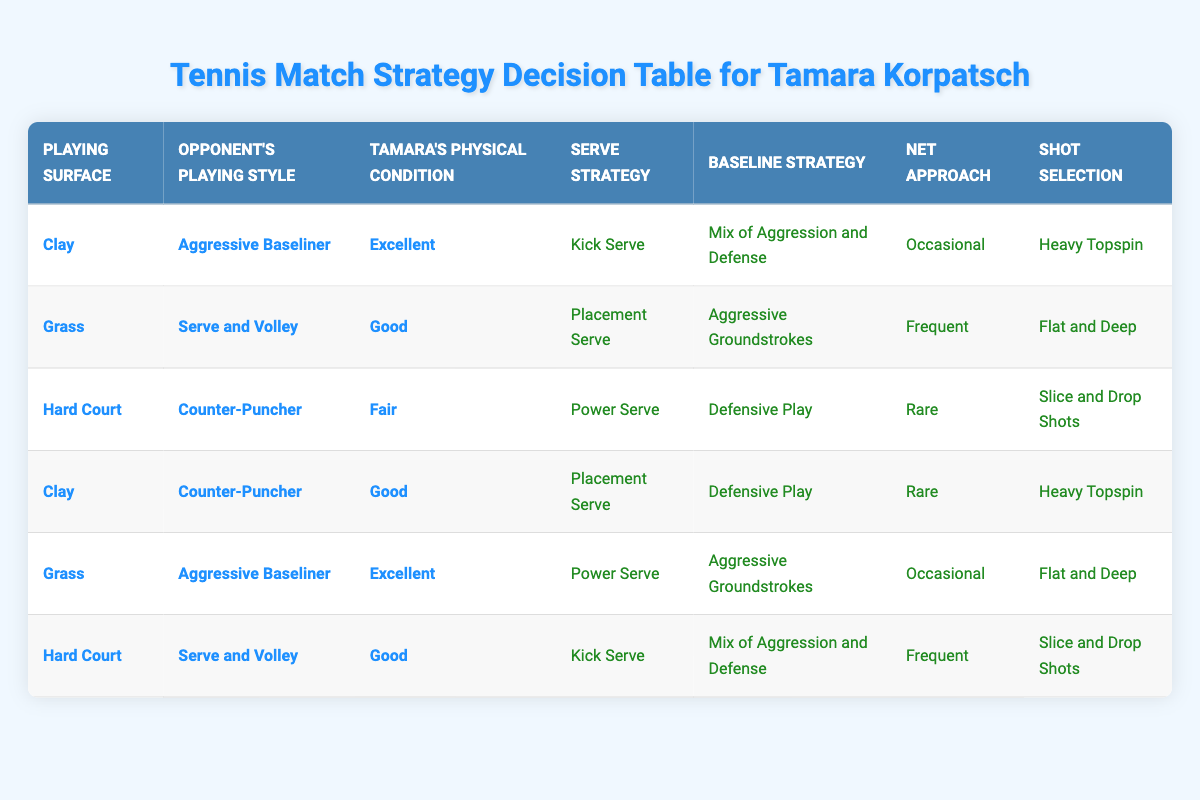What serve strategy is recommended when playing on clay against an aggressive baseliner with excellent physical condition? According to the table, when the playing surface is clay, facing an aggressive baseliner, and Tamara's physical condition is excellent, the recommended serve strategy is a "Kick Serve."
Answer: Kick Serve Does the table suggest a baseline strategy for Tamara when she plays on grass against a serve and volley opponent with good physical condition? Yes, the table specifies that on grass against a serve and volley opponent with good physical condition, the recommended baseline strategy is "Aggressive Groundstrokes."
Answer: Yes How many distinct serve strategies are listed in the table for hard court matches? The table shows two distinct scenarios for hard court matches: one with a counter-puncher and one with a serve and volley opponent. The serve strategies listed for these situations are "Power Serve" and "Kick Serve," respectively, indicating there are two distinct serve strategies for hard court.
Answer: 2 Is it true that Tamara should approach the net frequently when playing an aggressive baseliner on grass with excellent physical condition? Yes, the table indicates that when Tamara plays on grass against an aggressive baseliner with excellent physical condition, her net approach should be "Frequent."
Answer: Yes What is the difference in shot selection recommendations between playing on hard courts against a counter-puncher with fair condition and playing on clay against a counter-puncher with good condition? For hard courts against a counter-puncher with fair physical condition, the shot selection is "Slice and Drop Shots." In contrast, on clay against a counter-puncher with good condition, the shot selection is "Heavy Topspin." Thus, the difference is one strategy emphasizes slice shots while the other emphasizes heavy topspin.
Answer: One is slice and drop shots; the other is heavy topspin 